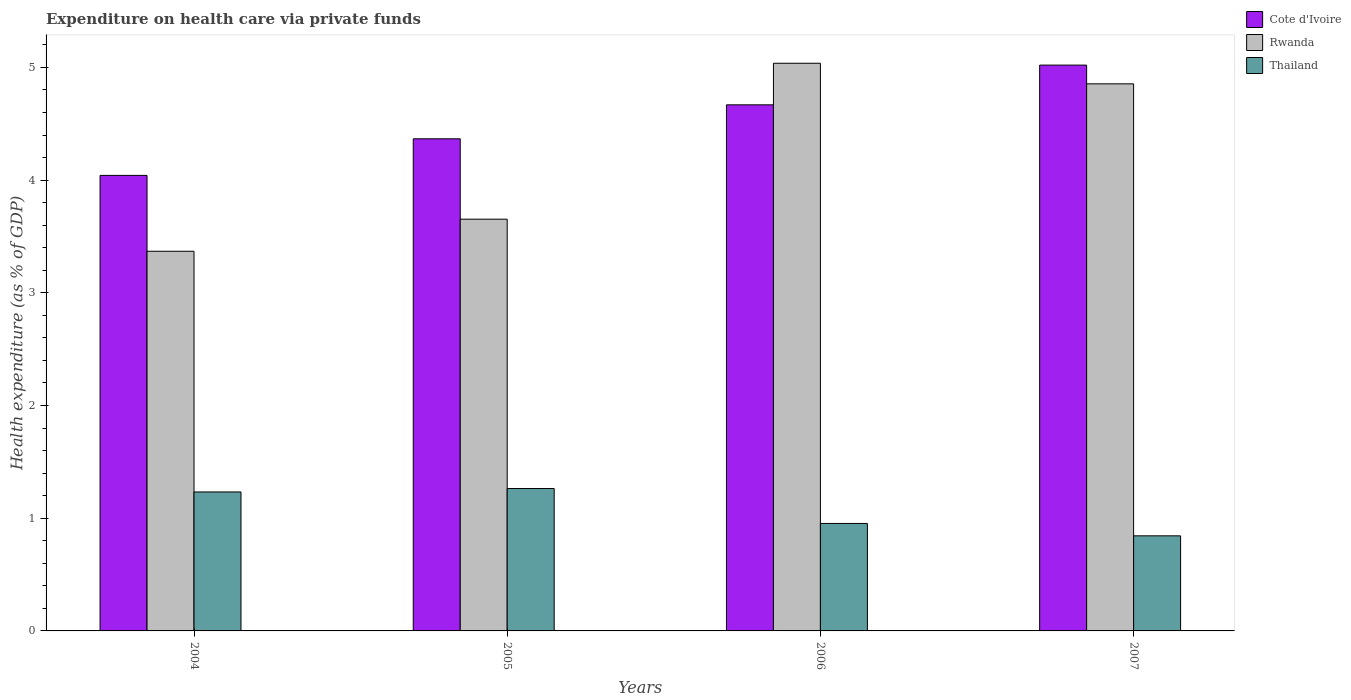How many different coloured bars are there?
Your response must be concise. 3. How many groups of bars are there?
Make the answer very short. 4. Are the number of bars per tick equal to the number of legend labels?
Keep it short and to the point. Yes. How many bars are there on the 3rd tick from the left?
Ensure brevity in your answer.  3. What is the label of the 2nd group of bars from the left?
Your response must be concise. 2005. In how many cases, is the number of bars for a given year not equal to the number of legend labels?
Your answer should be compact. 0. What is the expenditure made on health care in Cote d'Ivoire in 2007?
Offer a terse response. 5.02. Across all years, what is the maximum expenditure made on health care in Thailand?
Give a very brief answer. 1.26. Across all years, what is the minimum expenditure made on health care in Thailand?
Make the answer very short. 0.84. In which year was the expenditure made on health care in Rwanda maximum?
Your answer should be very brief. 2006. What is the total expenditure made on health care in Thailand in the graph?
Your answer should be very brief. 4.29. What is the difference between the expenditure made on health care in Cote d'Ivoire in 2006 and that in 2007?
Make the answer very short. -0.35. What is the difference between the expenditure made on health care in Thailand in 2007 and the expenditure made on health care in Rwanda in 2006?
Your response must be concise. -4.19. What is the average expenditure made on health care in Rwanda per year?
Your answer should be very brief. 4.23. In the year 2007, what is the difference between the expenditure made on health care in Cote d'Ivoire and expenditure made on health care in Rwanda?
Ensure brevity in your answer.  0.17. In how many years, is the expenditure made on health care in Rwanda greater than 0.6000000000000001 %?
Your answer should be very brief. 4. What is the ratio of the expenditure made on health care in Thailand in 2005 to that in 2006?
Ensure brevity in your answer.  1.32. Is the expenditure made on health care in Thailand in 2006 less than that in 2007?
Your response must be concise. No. Is the difference between the expenditure made on health care in Cote d'Ivoire in 2004 and 2007 greater than the difference between the expenditure made on health care in Rwanda in 2004 and 2007?
Provide a short and direct response. Yes. What is the difference between the highest and the second highest expenditure made on health care in Cote d'Ivoire?
Provide a short and direct response. 0.35. What is the difference between the highest and the lowest expenditure made on health care in Rwanda?
Make the answer very short. 1.67. What does the 3rd bar from the left in 2007 represents?
Give a very brief answer. Thailand. What does the 2nd bar from the right in 2005 represents?
Provide a short and direct response. Rwanda. Is it the case that in every year, the sum of the expenditure made on health care in Rwanda and expenditure made on health care in Cote d'Ivoire is greater than the expenditure made on health care in Thailand?
Offer a very short reply. Yes. How many bars are there?
Your answer should be compact. 12. Are all the bars in the graph horizontal?
Provide a short and direct response. No. How many years are there in the graph?
Your response must be concise. 4. What is the difference between two consecutive major ticks on the Y-axis?
Give a very brief answer. 1. Does the graph contain any zero values?
Your response must be concise. No. What is the title of the graph?
Provide a succinct answer. Expenditure on health care via private funds. What is the label or title of the X-axis?
Offer a terse response. Years. What is the label or title of the Y-axis?
Make the answer very short. Health expenditure (as % of GDP). What is the Health expenditure (as % of GDP) of Cote d'Ivoire in 2004?
Provide a succinct answer. 4.04. What is the Health expenditure (as % of GDP) of Rwanda in 2004?
Your answer should be compact. 3.37. What is the Health expenditure (as % of GDP) of Thailand in 2004?
Your response must be concise. 1.23. What is the Health expenditure (as % of GDP) in Cote d'Ivoire in 2005?
Give a very brief answer. 4.37. What is the Health expenditure (as % of GDP) of Rwanda in 2005?
Give a very brief answer. 3.65. What is the Health expenditure (as % of GDP) of Thailand in 2005?
Your response must be concise. 1.26. What is the Health expenditure (as % of GDP) in Cote d'Ivoire in 2006?
Give a very brief answer. 4.67. What is the Health expenditure (as % of GDP) in Rwanda in 2006?
Your response must be concise. 5.04. What is the Health expenditure (as % of GDP) of Thailand in 2006?
Ensure brevity in your answer.  0.95. What is the Health expenditure (as % of GDP) in Cote d'Ivoire in 2007?
Ensure brevity in your answer.  5.02. What is the Health expenditure (as % of GDP) of Rwanda in 2007?
Provide a short and direct response. 4.85. What is the Health expenditure (as % of GDP) in Thailand in 2007?
Give a very brief answer. 0.84. Across all years, what is the maximum Health expenditure (as % of GDP) of Cote d'Ivoire?
Offer a very short reply. 5.02. Across all years, what is the maximum Health expenditure (as % of GDP) in Rwanda?
Your answer should be very brief. 5.04. Across all years, what is the maximum Health expenditure (as % of GDP) in Thailand?
Provide a short and direct response. 1.26. Across all years, what is the minimum Health expenditure (as % of GDP) in Cote d'Ivoire?
Keep it short and to the point. 4.04. Across all years, what is the minimum Health expenditure (as % of GDP) of Rwanda?
Ensure brevity in your answer.  3.37. Across all years, what is the minimum Health expenditure (as % of GDP) of Thailand?
Give a very brief answer. 0.84. What is the total Health expenditure (as % of GDP) in Cote d'Ivoire in the graph?
Provide a succinct answer. 18.1. What is the total Health expenditure (as % of GDP) of Rwanda in the graph?
Keep it short and to the point. 16.91. What is the total Health expenditure (as % of GDP) of Thailand in the graph?
Your response must be concise. 4.29. What is the difference between the Health expenditure (as % of GDP) in Cote d'Ivoire in 2004 and that in 2005?
Your answer should be compact. -0.32. What is the difference between the Health expenditure (as % of GDP) in Rwanda in 2004 and that in 2005?
Keep it short and to the point. -0.28. What is the difference between the Health expenditure (as % of GDP) of Thailand in 2004 and that in 2005?
Provide a short and direct response. -0.03. What is the difference between the Health expenditure (as % of GDP) in Cote d'Ivoire in 2004 and that in 2006?
Give a very brief answer. -0.63. What is the difference between the Health expenditure (as % of GDP) of Rwanda in 2004 and that in 2006?
Make the answer very short. -1.67. What is the difference between the Health expenditure (as % of GDP) of Thailand in 2004 and that in 2006?
Your answer should be compact. 0.28. What is the difference between the Health expenditure (as % of GDP) in Cote d'Ivoire in 2004 and that in 2007?
Provide a short and direct response. -0.98. What is the difference between the Health expenditure (as % of GDP) in Rwanda in 2004 and that in 2007?
Your answer should be compact. -1.49. What is the difference between the Health expenditure (as % of GDP) of Thailand in 2004 and that in 2007?
Your response must be concise. 0.39. What is the difference between the Health expenditure (as % of GDP) in Cote d'Ivoire in 2005 and that in 2006?
Your response must be concise. -0.3. What is the difference between the Health expenditure (as % of GDP) of Rwanda in 2005 and that in 2006?
Provide a succinct answer. -1.38. What is the difference between the Health expenditure (as % of GDP) in Thailand in 2005 and that in 2006?
Offer a terse response. 0.31. What is the difference between the Health expenditure (as % of GDP) in Cote d'Ivoire in 2005 and that in 2007?
Offer a very short reply. -0.65. What is the difference between the Health expenditure (as % of GDP) in Rwanda in 2005 and that in 2007?
Your response must be concise. -1.2. What is the difference between the Health expenditure (as % of GDP) of Thailand in 2005 and that in 2007?
Your response must be concise. 0.42. What is the difference between the Health expenditure (as % of GDP) of Cote d'Ivoire in 2006 and that in 2007?
Offer a very short reply. -0.35. What is the difference between the Health expenditure (as % of GDP) of Rwanda in 2006 and that in 2007?
Keep it short and to the point. 0.18. What is the difference between the Health expenditure (as % of GDP) in Thailand in 2006 and that in 2007?
Your answer should be compact. 0.11. What is the difference between the Health expenditure (as % of GDP) of Cote d'Ivoire in 2004 and the Health expenditure (as % of GDP) of Rwanda in 2005?
Provide a succinct answer. 0.39. What is the difference between the Health expenditure (as % of GDP) in Cote d'Ivoire in 2004 and the Health expenditure (as % of GDP) in Thailand in 2005?
Offer a very short reply. 2.78. What is the difference between the Health expenditure (as % of GDP) of Rwanda in 2004 and the Health expenditure (as % of GDP) of Thailand in 2005?
Provide a short and direct response. 2.11. What is the difference between the Health expenditure (as % of GDP) in Cote d'Ivoire in 2004 and the Health expenditure (as % of GDP) in Rwanda in 2006?
Your answer should be compact. -0.99. What is the difference between the Health expenditure (as % of GDP) of Cote d'Ivoire in 2004 and the Health expenditure (as % of GDP) of Thailand in 2006?
Offer a very short reply. 3.09. What is the difference between the Health expenditure (as % of GDP) in Rwanda in 2004 and the Health expenditure (as % of GDP) in Thailand in 2006?
Ensure brevity in your answer.  2.42. What is the difference between the Health expenditure (as % of GDP) of Cote d'Ivoire in 2004 and the Health expenditure (as % of GDP) of Rwanda in 2007?
Keep it short and to the point. -0.81. What is the difference between the Health expenditure (as % of GDP) of Cote d'Ivoire in 2004 and the Health expenditure (as % of GDP) of Thailand in 2007?
Provide a short and direct response. 3.2. What is the difference between the Health expenditure (as % of GDP) in Rwanda in 2004 and the Health expenditure (as % of GDP) in Thailand in 2007?
Provide a succinct answer. 2.52. What is the difference between the Health expenditure (as % of GDP) of Cote d'Ivoire in 2005 and the Health expenditure (as % of GDP) of Rwanda in 2006?
Your response must be concise. -0.67. What is the difference between the Health expenditure (as % of GDP) of Cote d'Ivoire in 2005 and the Health expenditure (as % of GDP) of Thailand in 2006?
Keep it short and to the point. 3.41. What is the difference between the Health expenditure (as % of GDP) in Rwanda in 2005 and the Health expenditure (as % of GDP) in Thailand in 2006?
Provide a short and direct response. 2.7. What is the difference between the Health expenditure (as % of GDP) of Cote d'Ivoire in 2005 and the Health expenditure (as % of GDP) of Rwanda in 2007?
Offer a terse response. -0.49. What is the difference between the Health expenditure (as % of GDP) of Cote d'Ivoire in 2005 and the Health expenditure (as % of GDP) of Thailand in 2007?
Offer a terse response. 3.52. What is the difference between the Health expenditure (as % of GDP) of Rwanda in 2005 and the Health expenditure (as % of GDP) of Thailand in 2007?
Your answer should be compact. 2.81. What is the difference between the Health expenditure (as % of GDP) of Cote d'Ivoire in 2006 and the Health expenditure (as % of GDP) of Rwanda in 2007?
Your answer should be very brief. -0.19. What is the difference between the Health expenditure (as % of GDP) of Cote d'Ivoire in 2006 and the Health expenditure (as % of GDP) of Thailand in 2007?
Provide a short and direct response. 3.82. What is the difference between the Health expenditure (as % of GDP) in Rwanda in 2006 and the Health expenditure (as % of GDP) in Thailand in 2007?
Offer a terse response. 4.19. What is the average Health expenditure (as % of GDP) of Cote d'Ivoire per year?
Provide a short and direct response. 4.52. What is the average Health expenditure (as % of GDP) in Rwanda per year?
Your response must be concise. 4.23. What is the average Health expenditure (as % of GDP) of Thailand per year?
Offer a very short reply. 1.07. In the year 2004, what is the difference between the Health expenditure (as % of GDP) of Cote d'Ivoire and Health expenditure (as % of GDP) of Rwanda?
Give a very brief answer. 0.67. In the year 2004, what is the difference between the Health expenditure (as % of GDP) in Cote d'Ivoire and Health expenditure (as % of GDP) in Thailand?
Provide a succinct answer. 2.81. In the year 2004, what is the difference between the Health expenditure (as % of GDP) in Rwanda and Health expenditure (as % of GDP) in Thailand?
Offer a very short reply. 2.14. In the year 2005, what is the difference between the Health expenditure (as % of GDP) of Cote d'Ivoire and Health expenditure (as % of GDP) of Rwanda?
Your answer should be compact. 0.71. In the year 2005, what is the difference between the Health expenditure (as % of GDP) of Cote d'Ivoire and Health expenditure (as % of GDP) of Thailand?
Offer a very short reply. 3.1. In the year 2005, what is the difference between the Health expenditure (as % of GDP) in Rwanda and Health expenditure (as % of GDP) in Thailand?
Ensure brevity in your answer.  2.39. In the year 2006, what is the difference between the Health expenditure (as % of GDP) in Cote d'Ivoire and Health expenditure (as % of GDP) in Rwanda?
Make the answer very short. -0.37. In the year 2006, what is the difference between the Health expenditure (as % of GDP) of Cote d'Ivoire and Health expenditure (as % of GDP) of Thailand?
Ensure brevity in your answer.  3.71. In the year 2006, what is the difference between the Health expenditure (as % of GDP) of Rwanda and Health expenditure (as % of GDP) of Thailand?
Give a very brief answer. 4.08. In the year 2007, what is the difference between the Health expenditure (as % of GDP) in Cote d'Ivoire and Health expenditure (as % of GDP) in Rwanda?
Your answer should be compact. 0.17. In the year 2007, what is the difference between the Health expenditure (as % of GDP) of Cote d'Ivoire and Health expenditure (as % of GDP) of Thailand?
Offer a very short reply. 4.18. In the year 2007, what is the difference between the Health expenditure (as % of GDP) in Rwanda and Health expenditure (as % of GDP) in Thailand?
Make the answer very short. 4.01. What is the ratio of the Health expenditure (as % of GDP) of Cote d'Ivoire in 2004 to that in 2005?
Provide a short and direct response. 0.93. What is the ratio of the Health expenditure (as % of GDP) of Rwanda in 2004 to that in 2005?
Make the answer very short. 0.92. What is the ratio of the Health expenditure (as % of GDP) in Thailand in 2004 to that in 2005?
Your answer should be compact. 0.98. What is the ratio of the Health expenditure (as % of GDP) in Cote d'Ivoire in 2004 to that in 2006?
Your answer should be very brief. 0.87. What is the ratio of the Health expenditure (as % of GDP) of Rwanda in 2004 to that in 2006?
Give a very brief answer. 0.67. What is the ratio of the Health expenditure (as % of GDP) of Thailand in 2004 to that in 2006?
Your response must be concise. 1.29. What is the ratio of the Health expenditure (as % of GDP) of Cote d'Ivoire in 2004 to that in 2007?
Offer a terse response. 0.81. What is the ratio of the Health expenditure (as % of GDP) of Rwanda in 2004 to that in 2007?
Your answer should be very brief. 0.69. What is the ratio of the Health expenditure (as % of GDP) in Thailand in 2004 to that in 2007?
Your response must be concise. 1.46. What is the ratio of the Health expenditure (as % of GDP) of Cote d'Ivoire in 2005 to that in 2006?
Make the answer very short. 0.94. What is the ratio of the Health expenditure (as % of GDP) of Rwanda in 2005 to that in 2006?
Ensure brevity in your answer.  0.73. What is the ratio of the Health expenditure (as % of GDP) of Thailand in 2005 to that in 2006?
Provide a short and direct response. 1.32. What is the ratio of the Health expenditure (as % of GDP) in Cote d'Ivoire in 2005 to that in 2007?
Your answer should be very brief. 0.87. What is the ratio of the Health expenditure (as % of GDP) of Rwanda in 2005 to that in 2007?
Provide a short and direct response. 0.75. What is the ratio of the Health expenditure (as % of GDP) of Thailand in 2005 to that in 2007?
Offer a terse response. 1.5. What is the ratio of the Health expenditure (as % of GDP) in Cote d'Ivoire in 2006 to that in 2007?
Your response must be concise. 0.93. What is the ratio of the Health expenditure (as % of GDP) in Rwanda in 2006 to that in 2007?
Your answer should be very brief. 1.04. What is the ratio of the Health expenditure (as % of GDP) of Thailand in 2006 to that in 2007?
Offer a very short reply. 1.13. What is the difference between the highest and the second highest Health expenditure (as % of GDP) in Cote d'Ivoire?
Offer a terse response. 0.35. What is the difference between the highest and the second highest Health expenditure (as % of GDP) in Rwanda?
Offer a terse response. 0.18. What is the difference between the highest and the second highest Health expenditure (as % of GDP) in Thailand?
Provide a short and direct response. 0.03. What is the difference between the highest and the lowest Health expenditure (as % of GDP) in Cote d'Ivoire?
Make the answer very short. 0.98. What is the difference between the highest and the lowest Health expenditure (as % of GDP) of Rwanda?
Ensure brevity in your answer.  1.67. What is the difference between the highest and the lowest Health expenditure (as % of GDP) of Thailand?
Your answer should be compact. 0.42. 